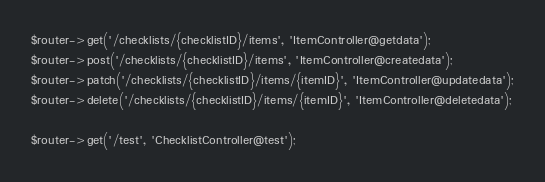<code> <loc_0><loc_0><loc_500><loc_500><_PHP_>$router->get('/checklists/{checklistID}/items', 'ItemController@getdata');
$router->post('/checklists/{checklistID}/items', 'ItemController@createdata');
$router->patch('/checklists/{checklistID}/items/{itemID}', 'ItemController@updatedata');
$router->delete('/checklists/{checklistID}/items/{itemID}', 'ItemController@deletedata');

$router->get('/test', 'ChecklistController@test');

</code> 